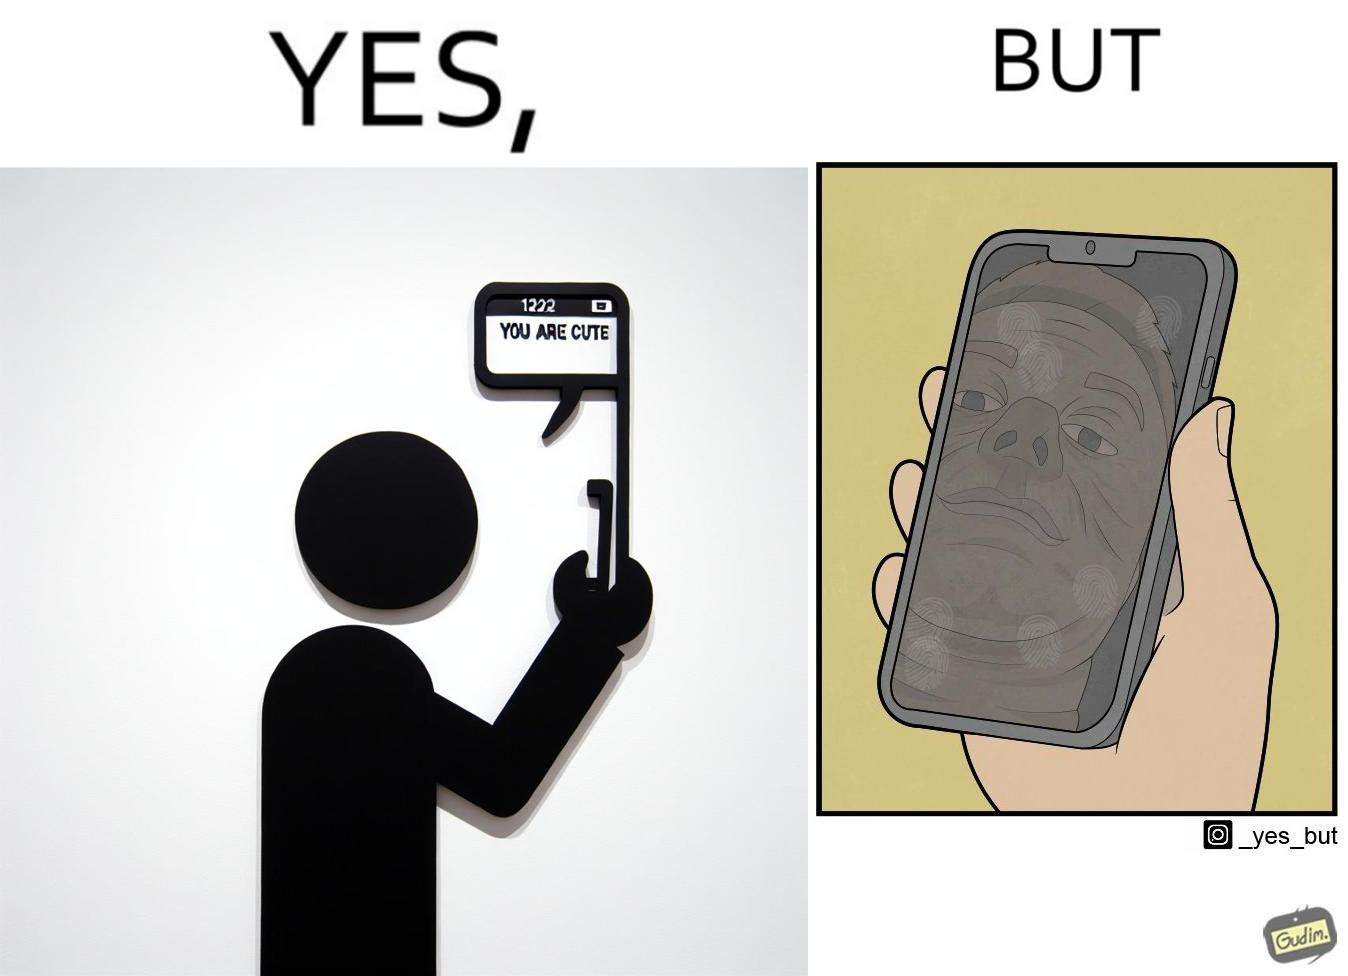What do you see in each half of this image? In the left part of the image: someone holding a phone and the screen shows a message from someone as "You are cute" In the right part of the image: a person, probably a man, viewing at his face in the phone screen after turned off, the phone screen has touch marks on it 